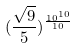<formula> <loc_0><loc_0><loc_500><loc_500>( \frac { \sqrt { 9 } } { 5 } ) ^ { \frac { 1 0 ^ { 1 0 } } { 1 0 } }</formula> 